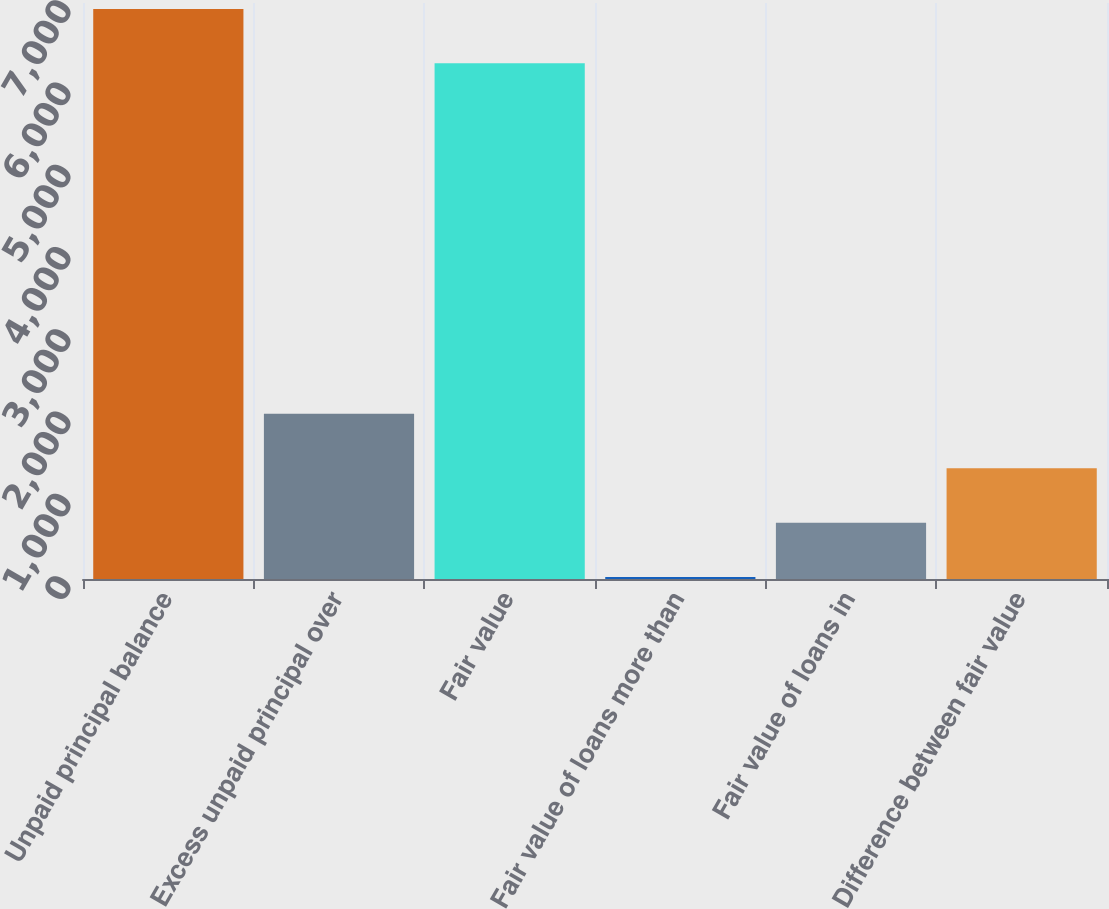Convert chart to OTSL. <chart><loc_0><loc_0><loc_500><loc_500><bar_chart><fcel>Unpaid principal balance<fcel>Excess unpaid principal over<fcel>Fair value<fcel>Fair value of loans more than<fcel>Fair value of loans in<fcel>Difference between fair value<nl><fcel>6928.1<fcel>2007.3<fcel>6267<fcel>24<fcel>685.1<fcel>1346.2<nl></chart> 